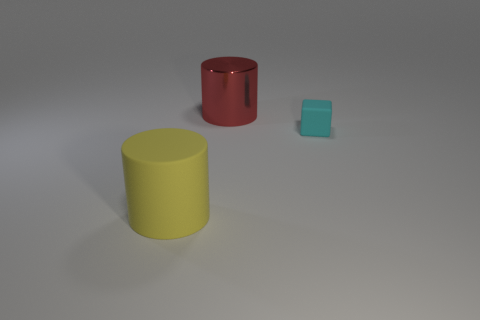How many blue objects are shiny cylinders or big matte cylinders? In the image, there is only one blue object which is a small matte cube, so the answer to how many blue objects are shiny cylinders or big matte cylinders would be none. However, if you're curious about the characteristics of the objects presented, we have a glossy red cylinder, a big matte yellow cylinder, and a small matte blue cube. 